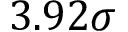<formula> <loc_0><loc_0><loc_500><loc_500>3 . 9 2 \sigma</formula> 